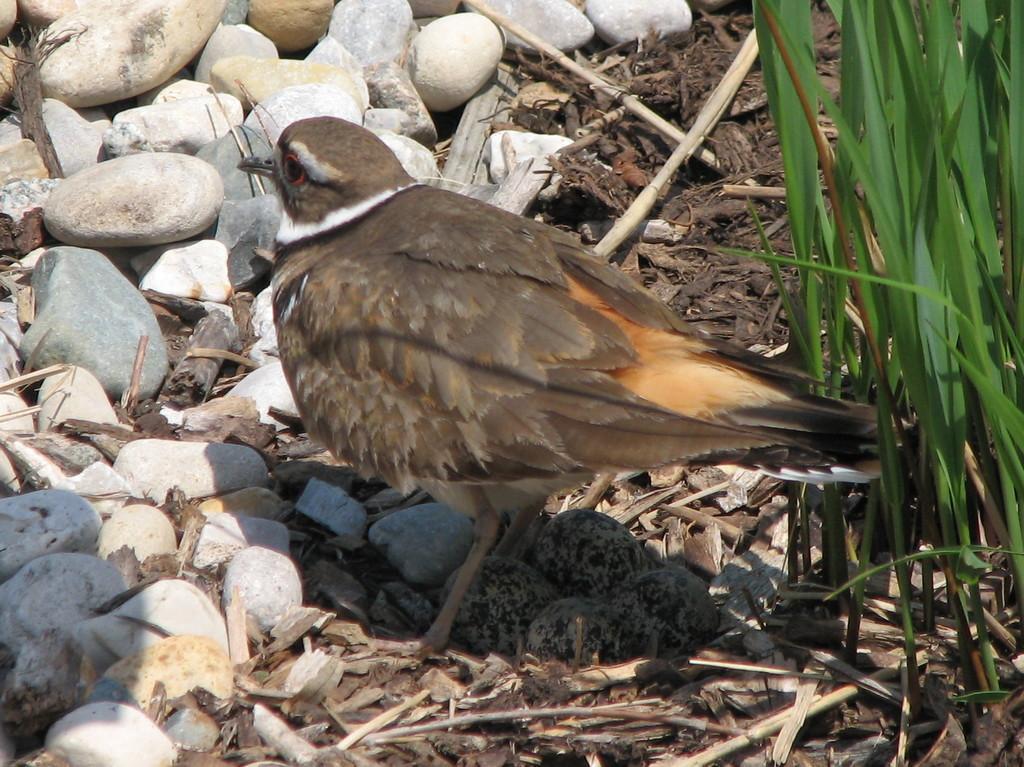How would you summarize this image in a sentence or two? In this image we can see one bird, four bird eggs on the ground, some stones, some dried sticks on the ground and some grass on the right side of the image. 